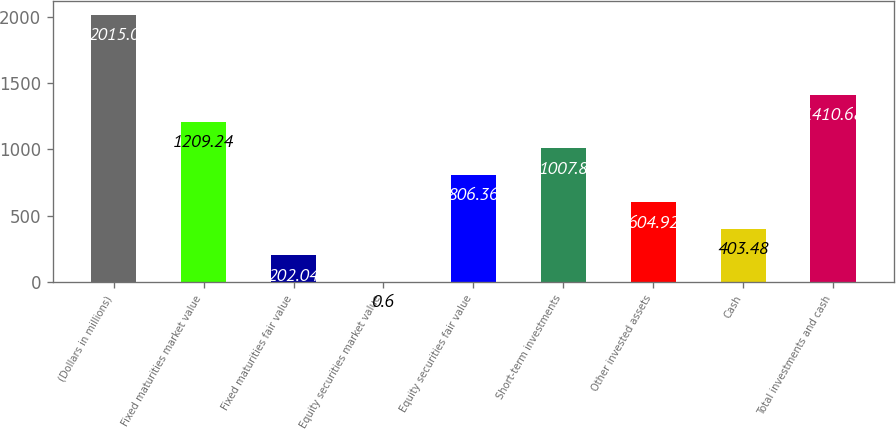Convert chart to OTSL. <chart><loc_0><loc_0><loc_500><loc_500><bar_chart><fcel>(Dollars in millions)<fcel>Fixed maturities market value<fcel>Fixed maturities fair value<fcel>Equity securities market value<fcel>Equity securities fair value<fcel>Short-term investments<fcel>Other invested assets<fcel>Cash<fcel>Total investments and cash<nl><fcel>2015<fcel>1209.24<fcel>202.04<fcel>0.6<fcel>806.36<fcel>1007.8<fcel>604.92<fcel>403.48<fcel>1410.68<nl></chart> 